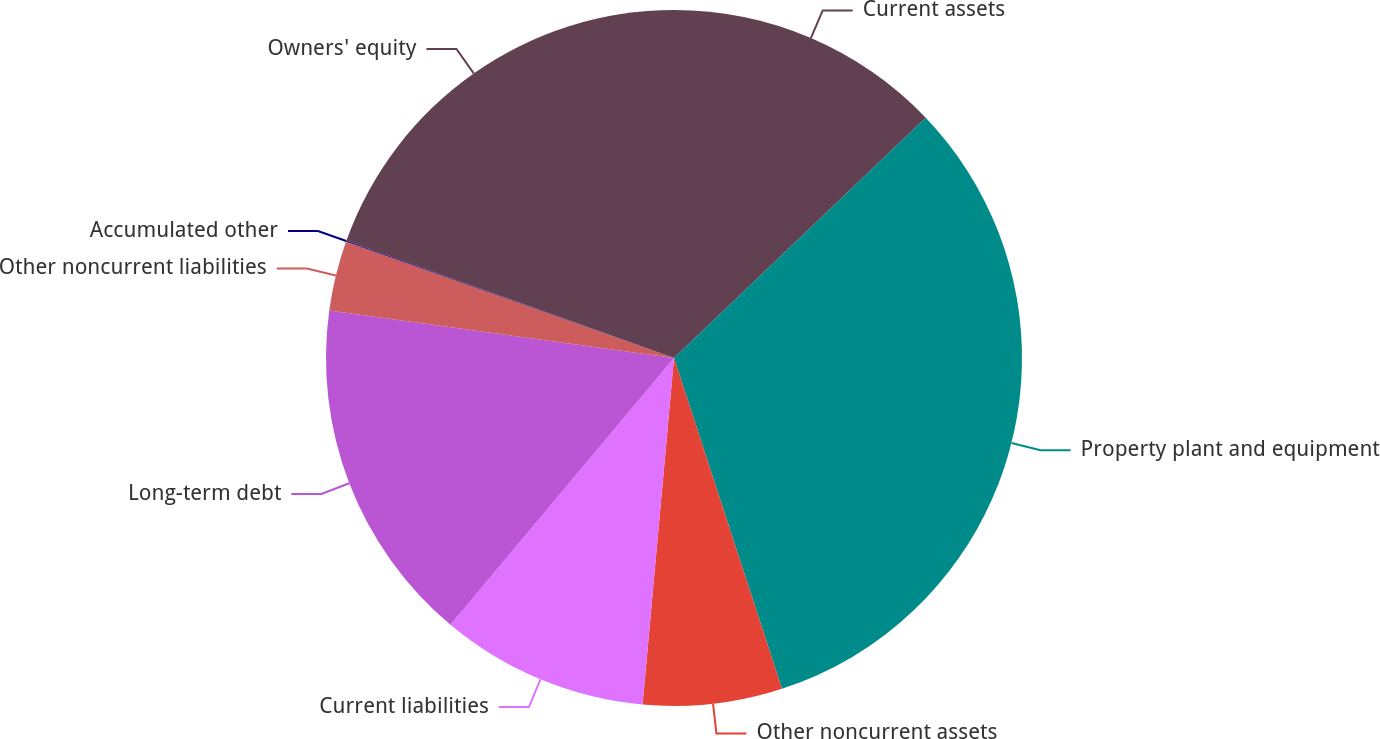Convert chart. <chart><loc_0><loc_0><loc_500><loc_500><pie_chart><fcel>Current assets<fcel>Property plant and equipment<fcel>Other noncurrent assets<fcel>Current liabilities<fcel>Long-term debt<fcel>Other noncurrent liabilities<fcel>Accumulated other<fcel>Owners' equity<nl><fcel>12.87%<fcel>32.11%<fcel>6.46%<fcel>9.66%<fcel>16.08%<fcel>3.25%<fcel>0.05%<fcel>19.52%<nl></chart> 